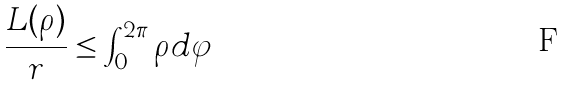Convert formula to latex. <formula><loc_0><loc_0><loc_500><loc_500>\frac { L ( \rho ) } { r } \leq \int _ { 0 } ^ { 2 \pi } \rho d \varphi</formula> 